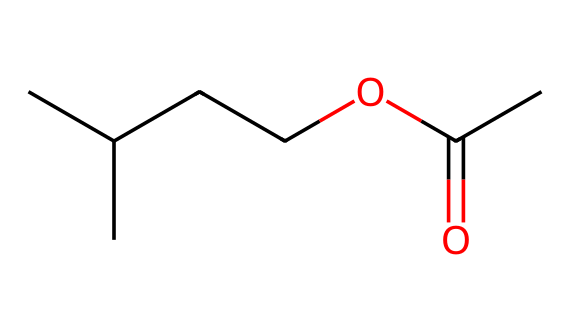What is the molecular formula of isoamyl acetate? To find the molecular formula, we need to identify the number of each type of atom present in the structure. The SMILES representation shows five carbons (C), ten hydrogens (H), and two oxygens (O), leading to the formula C5H10O2.
Answer: C5H10O2 How many oxygen atoms are present in isoamyl acetate? From the SMILES representation, we can see that there are two distinct oxygen atoms in the structure.
Answer: 2 What is the functional group observed in isoamyl acetate? The SMILES indicates that isoamyl acetate has an ester functional group, identified by the -O- connected to a carbonyl (C=O).
Answer: ester What type of reaction would isoamyl acetate undergo to form an alcohol? Isoamyl acetate can undergo hydrolysis, a reaction with water that breaks the ester bond to yield an alcohol and a carboxylic acid.
Answer: hydrolysis What property of isoamyl acetate gives it a banana flavor? The specific arrangement of atoms, particularly the ester linkage, is responsible for the fruity aroma associated with isoamyl acetate.
Answer: fruity aroma How many total bonds are present in isoamyl acetate? By analyzing the structure, we can count the total number of bonds between carbon, hydrogen, and oxygen atoms in the SMILES representation, concluding that there are fourteen bonds in total.
Answer: 14 